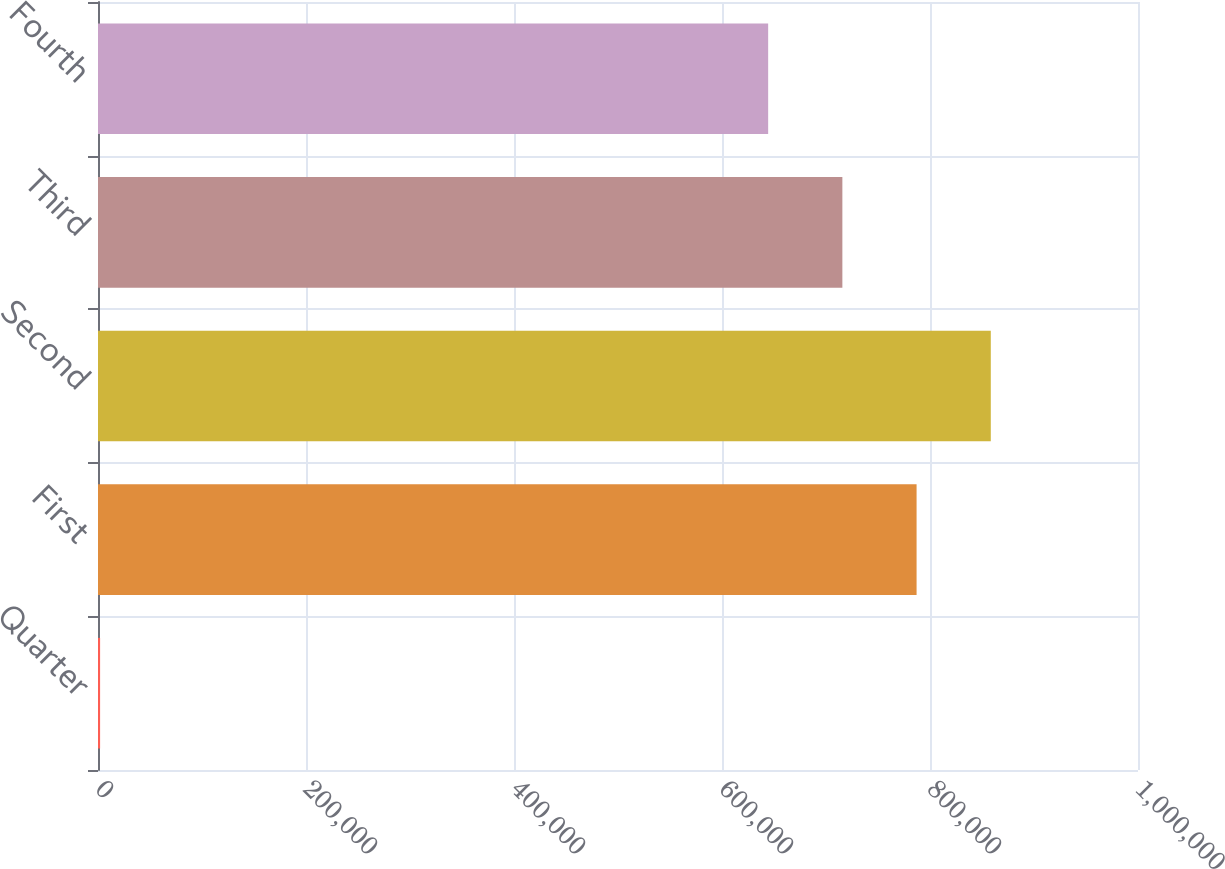Convert chart. <chart><loc_0><loc_0><loc_500><loc_500><bar_chart><fcel>Quarter<fcel>First<fcel>Second<fcel>Third<fcel>Fourth<nl><fcel>2011<fcel>787099<fcel>858456<fcel>715741<fcel>644383<nl></chart> 